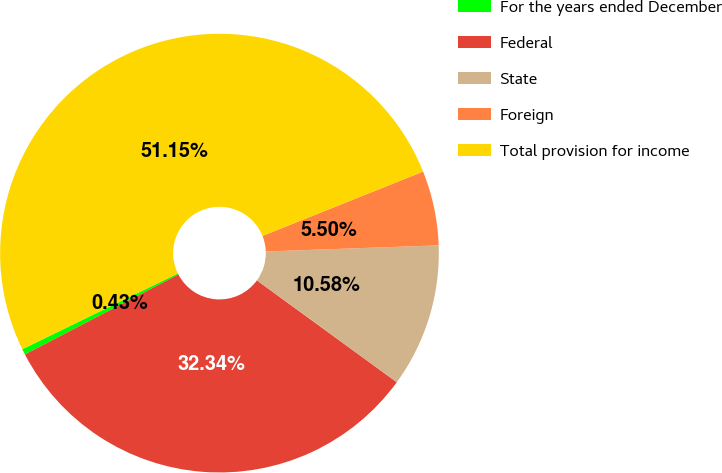<chart> <loc_0><loc_0><loc_500><loc_500><pie_chart><fcel>For the years ended December<fcel>Federal<fcel>State<fcel>Foreign<fcel>Total provision for income<nl><fcel>0.43%<fcel>32.34%<fcel>10.58%<fcel>5.5%<fcel>51.15%<nl></chart> 